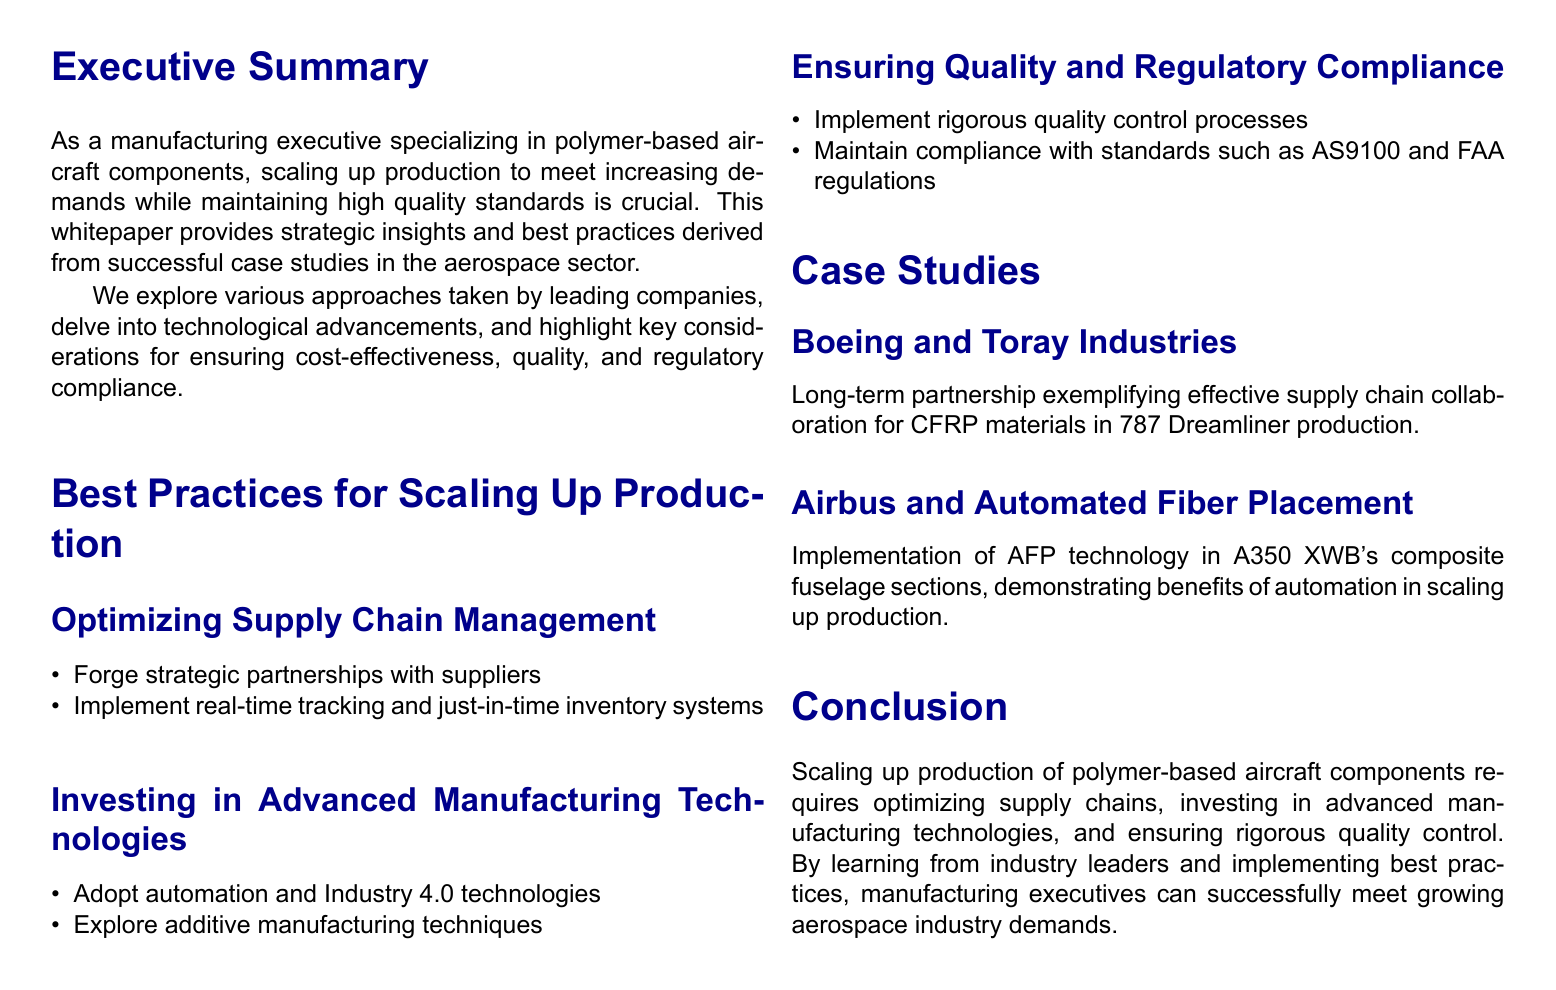What is the main focus of the whitepaper? The whitepaper primarily focuses on strategies for increasing production of polymer-based aircraft components in the aerospace industry.
Answer: scaling up production of polymer-based aircraft components Which company is highlighted for its partnership in the case study? Boeing is mentioned as a company that has a significant long-term partnership with Toray Industries for CFRP materials.
Answer: Boeing What technology is explored for advanced manufacturing? Additive manufacturing techniques are identified as a key area for investment in advanced manufacturing technologies.
Answer: Additive manufacturing What is one of the quality standards mentioned? AS9100 is one of the critical quality standards referenced in the context of regulatory compliance.
Answer: AS9100 How many case studies are presented in the document? Two significant case studies are discussed, providing examples of best practices in production scaling.
Answer: 2 What does AFP stand for in the document? AFP stands for Automated Fiber Placement, which is mentioned as a technology used in Airbus production.
Answer: Automated Fiber Placement What key practice is essential for supply chain management? Forging strategic partnerships with suppliers is identified as a vital practice for optimizing supply chain management.
Answer: Strategic partnerships Which aerospace company implemented technology in A350 XWB production? Airbus is the aerospace company noted for implementing AFP technology in the A350 XWB's composite fuselage sections.
Answer: Airbus What is the conclusion about scaling up production? The conclusion emphasizes the need for optimizing supply chains, technology investment, and quality control in scaling up production.
Answer: Optimizing supply chains, investing in technologies, ensuring quality control 